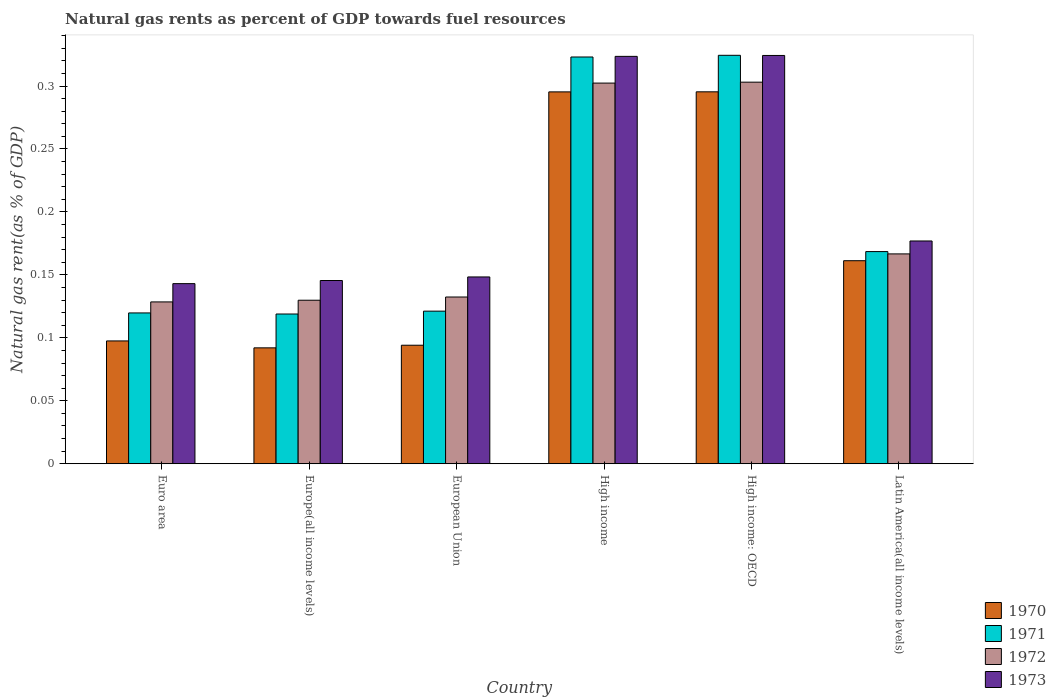How many different coloured bars are there?
Your response must be concise. 4. Are the number of bars on each tick of the X-axis equal?
Your answer should be compact. Yes. What is the label of the 1st group of bars from the left?
Make the answer very short. Euro area. In how many cases, is the number of bars for a given country not equal to the number of legend labels?
Offer a very short reply. 0. What is the natural gas rent in 1970 in Latin America(all income levels)?
Your response must be concise. 0.16. Across all countries, what is the maximum natural gas rent in 1971?
Keep it short and to the point. 0.32. Across all countries, what is the minimum natural gas rent in 1973?
Provide a succinct answer. 0.14. In which country was the natural gas rent in 1971 maximum?
Make the answer very short. High income: OECD. In which country was the natural gas rent in 1972 minimum?
Offer a terse response. Euro area. What is the total natural gas rent in 1972 in the graph?
Make the answer very short. 1.16. What is the difference between the natural gas rent in 1971 in Euro area and that in Europe(all income levels)?
Give a very brief answer. 0. What is the difference between the natural gas rent in 1971 in Euro area and the natural gas rent in 1970 in High income?
Offer a very short reply. -0.18. What is the average natural gas rent in 1973 per country?
Offer a very short reply. 0.21. What is the difference between the natural gas rent of/in 1972 and natural gas rent of/in 1971 in High income: OECD?
Provide a succinct answer. -0.02. In how many countries, is the natural gas rent in 1972 greater than 0.17 %?
Provide a short and direct response. 2. What is the ratio of the natural gas rent in 1972 in High income to that in High income: OECD?
Make the answer very short. 1. Is the natural gas rent in 1971 in Euro area less than that in Europe(all income levels)?
Keep it short and to the point. No. What is the difference between the highest and the second highest natural gas rent in 1971?
Ensure brevity in your answer.  0. What is the difference between the highest and the lowest natural gas rent in 1971?
Give a very brief answer. 0.21. Is it the case that in every country, the sum of the natural gas rent in 1973 and natural gas rent in 1972 is greater than the sum of natural gas rent in 1971 and natural gas rent in 1970?
Your answer should be compact. No. What does the 1st bar from the right in Europe(all income levels) represents?
Offer a terse response. 1973. How many bars are there?
Provide a succinct answer. 24. Are all the bars in the graph horizontal?
Make the answer very short. No. How many countries are there in the graph?
Your response must be concise. 6. What is the difference between two consecutive major ticks on the Y-axis?
Your response must be concise. 0.05. Are the values on the major ticks of Y-axis written in scientific E-notation?
Make the answer very short. No. Does the graph contain any zero values?
Offer a terse response. No. How are the legend labels stacked?
Offer a terse response. Vertical. What is the title of the graph?
Give a very brief answer. Natural gas rents as percent of GDP towards fuel resources. Does "1997" appear as one of the legend labels in the graph?
Provide a short and direct response. No. What is the label or title of the Y-axis?
Your answer should be very brief. Natural gas rent(as % of GDP). What is the Natural gas rent(as % of GDP) in 1970 in Euro area?
Provide a short and direct response. 0.1. What is the Natural gas rent(as % of GDP) of 1971 in Euro area?
Your response must be concise. 0.12. What is the Natural gas rent(as % of GDP) of 1972 in Euro area?
Your answer should be compact. 0.13. What is the Natural gas rent(as % of GDP) of 1973 in Euro area?
Make the answer very short. 0.14. What is the Natural gas rent(as % of GDP) in 1970 in Europe(all income levels)?
Your response must be concise. 0.09. What is the Natural gas rent(as % of GDP) in 1971 in Europe(all income levels)?
Offer a very short reply. 0.12. What is the Natural gas rent(as % of GDP) in 1972 in Europe(all income levels)?
Give a very brief answer. 0.13. What is the Natural gas rent(as % of GDP) of 1973 in Europe(all income levels)?
Ensure brevity in your answer.  0.15. What is the Natural gas rent(as % of GDP) of 1970 in European Union?
Your response must be concise. 0.09. What is the Natural gas rent(as % of GDP) in 1971 in European Union?
Keep it short and to the point. 0.12. What is the Natural gas rent(as % of GDP) in 1972 in European Union?
Offer a terse response. 0.13. What is the Natural gas rent(as % of GDP) in 1973 in European Union?
Give a very brief answer. 0.15. What is the Natural gas rent(as % of GDP) of 1970 in High income?
Provide a succinct answer. 0.3. What is the Natural gas rent(as % of GDP) of 1971 in High income?
Make the answer very short. 0.32. What is the Natural gas rent(as % of GDP) of 1972 in High income?
Offer a terse response. 0.3. What is the Natural gas rent(as % of GDP) in 1973 in High income?
Offer a very short reply. 0.32. What is the Natural gas rent(as % of GDP) of 1970 in High income: OECD?
Provide a short and direct response. 0.3. What is the Natural gas rent(as % of GDP) of 1971 in High income: OECD?
Your answer should be very brief. 0.32. What is the Natural gas rent(as % of GDP) in 1972 in High income: OECD?
Your response must be concise. 0.3. What is the Natural gas rent(as % of GDP) in 1973 in High income: OECD?
Offer a terse response. 0.32. What is the Natural gas rent(as % of GDP) of 1970 in Latin America(all income levels)?
Provide a short and direct response. 0.16. What is the Natural gas rent(as % of GDP) in 1971 in Latin America(all income levels)?
Make the answer very short. 0.17. What is the Natural gas rent(as % of GDP) in 1972 in Latin America(all income levels)?
Your answer should be very brief. 0.17. What is the Natural gas rent(as % of GDP) in 1973 in Latin America(all income levels)?
Offer a very short reply. 0.18. Across all countries, what is the maximum Natural gas rent(as % of GDP) in 1970?
Your answer should be compact. 0.3. Across all countries, what is the maximum Natural gas rent(as % of GDP) of 1971?
Provide a succinct answer. 0.32. Across all countries, what is the maximum Natural gas rent(as % of GDP) of 1972?
Ensure brevity in your answer.  0.3. Across all countries, what is the maximum Natural gas rent(as % of GDP) of 1973?
Provide a succinct answer. 0.32. Across all countries, what is the minimum Natural gas rent(as % of GDP) in 1970?
Offer a terse response. 0.09. Across all countries, what is the minimum Natural gas rent(as % of GDP) of 1971?
Offer a very short reply. 0.12. Across all countries, what is the minimum Natural gas rent(as % of GDP) of 1972?
Your answer should be very brief. 0.13. Across all countries, what is the minimum Natural gas rent(as % of GDP) in 1973?
Ensure brevity in your answer.  0.14. What is the total Natural gas rent(as % of GDP) in 1970 in the graph?
Make the answer very short. 1.04. What is the total Natural gas rent(as % of GDP) of 1971 in the graph?
Provide a succinct answer. 1.18. What is the total Natural gas rent(as % of GDP) of 1972 in the graph?
Your response must be concise. 1.16. What is the total Natural gas rent(as % of GDP) in 1973 in the graph?
Offer a very short reply. 1.26. What is the difference between the Natural gas rent(as % of GDP) in 1970 in Euro area and that in Europe(all income levels)?
Give a very brief answer. 0.01. What is the difference between the Natural gas rent(as % of GDP) in 1971 in Euro area and that in Europe(all income levels)?
Make the answer very short. 0. What is the difference between the Natural gas rent(as % of GDP) of 1972 in Euro area and that in Europe(all income levels)?
Ensure brevity in your answer.  -0. What is the difference between the Natural gas rent(as % of GDP) of 1973 in Euro area and that in Europe(all income levels)?
Provide a succinct answer. -0. What is the difference between the Natural gas rent(as % of GDP) in 1970 in Euro area and that in European Union?
Your answer should be very brief. 0. What is the difference between the Natural gas rent(as % of GDP) of 1971 in Euro area and that in European Union?
Ensure brevity in your answer.  -0. What is the difference between the Natural gas rent(as % of GDP) of 1972 in Euro area and that in European Union?
Provide a short and direct response. -0. What is the difference between the Natural gas rent(as % of GDP) of 1973 in Euro area and that in European Union?
Ensure brevity in your answer.  -0.01. What is the difference between the Natural gas rent(as % of GDP) of 1970 in Euro area and that in High income?
Provide a short and direct response. -0.2. What is the difference between the Natural gas rent(as % of GDP) of 1971 in Euro area and that in High income?
Give a very brief answer. -0.2. What is the difference between the Natural gas rent(as % of GDP) in 1972 in Euro area and that in High income?
Ensure brevity in your answer.  -0.17. What is the difference between the Natural gas rent(as % of GDP) in 1973 in Euro area and that in High income?
Your answer should be very brief. -0.18. What is the difference between the Natural gas rent(as % of GDP) in 1970 in Euro area and that in High income: OECD?
Keep it short and to the point. -0.2. What is the difference between the Natural gas rent(as % of GDP) in 1971 in Euro area and that in High income: OECD?
Make the answer very short. -0.2. What is the difference between the Natural gas rent(as % of GDP) in 1972 in Euro area and that in High income: OECD?
Your answer should be very brief. -0.17. What is the difference between the Natural gas rent(as % of GDP) in 1973 in Euro area and that in High income: OECD?
Offer a very short reply. -0.18. What is the difference between the Natural gas rent(as % of GDP) in 1970 in Euro area and that in Latin America(all income levels)?
Your response must be concise. -0.06. What is the difference between the Natural gas rent(as % of GDP) of 1971 in Euro area and that in Latin America(all income levels)?
Your answer should be compact. -0.05. What is the difference between the Natural gas rent(as % of GDP) of 1972 in Euro area and that in Latin America(all income levels)?
Your answer should be compact. -0.04. What is the difference between the Natural gas rent(as % of GDP) of 1973 in Euro area and that in Latin America(all income levels)?
Ensure brevity in your answer.  -0.03. What is the difference between the Natural gas rent(as % of GDP) of 1970 in Europe(all income levels) and that in European Union?
Make the answer very short. -0. What is the difference between the Natural gas rent(as % of GDP) of 1971 in Europe(all income levels) and that in European Union?
Provide a succinct answer. -0. What is the difference between the Natural gas rent(as % of GDP) of 1972 in Europe(all income levels) and that in European Union?
Your answer should be very brief. -0. What is the difference between the Natural gas rent(as % of GDP) in 1973 in Europe(all income levels) and that in European Union?
Your answer should be compact. -0. What is the difference between the Natural gas rent(as % of GDP) of 1970 in Europe(all income levels) and that in High income?
Provide a succinct answer. -0.2. What is the difference between the Natural gas rent(as % of GDP) of 1971 in Europe(all income levels) and that in High income?
Make the answer very short. -0.2. What is the difference between the Natural gas rent(as % of GDP) in 1972 in Europe(all income levels) and that in High income?
Ensure brevity in your answer.  -0.17. What is the difference between the Natural gas rent(as % of GDP) in 1973 in Europe(all income levels) and that in High income?
Offer a very short reply. -0.18. What is the difference between the Natural gas rent(as % of GDP) of 1970 in Europe(all income levels) and that in High income: OECD?
Provide a short and direct response. -0.2. What is the difference between the Natural gas rent(as % of GDP) of 1971 in Europe(all income levels) and that in High income: OECD?
Provide a short and direct response. -0.21. What is the difference between the Natural gas rent(as % of GDP) in 1972 in Europe(all income levels) and that in High income: OECD?
Your response must be concise. -0.17. What is the difference between the Natural gas rent(as % of GDP) in 1973 in Europe(all income levels) and that in High income: OECD?
Make the answer very short. -0.18. What is the difference between the Natural gas rent(as % of GDP) of 1970 in Europe(all income levels) and that in Latin America(all income levels)?
Give a very brief answer. -0.07. What is the difference between the Natural gas rent(as % of GDP) in 1971 in Europe(all income levels) and that in Latin America(all income levels)?
Ensure brevity in your answer.  -0.05. What is the difference between the Natural gas rent(as % of GDP) of 1972 in Europe(all income levels) and that in Latin America(all income levels)?
Make the answer very short. -0.04. What is the difference between the Natural gas rent(as % of GDP) of 1973 in Europe(all income levels) and that in Latin America(all income levels)?
Offer a terse response. -0.03. What is the difference between the Natural gas rent(as % of GDP) of 1970 in European Union and that in High income?
Your response must be concise. -0.2. What is the difference between the Natural gas rent(as % of GDP) of 1971 in European Union and that in High income?
Make the answer very short. -0.2. What is the difference between the Natural gas rent(as % of GDP) in 1972 in European Union and that in High income?
Offer a very short reply. -0.17. What is the difference between the Natural gas rent(as % of GDP) in 1973 in European Union and that in High income?
Your answer should be compact. -0.18. What is the difference between the Natural gas rent(as % of GDP) in 1970 in European Union and that in High income: OECD?
Your response must be concise. -0.2. What is the difference between the Natural gas rent(as % of GDP) in 1971 in European Union and that in High income: OECD?
Offer a very short reply. -0.2. What is the difference between the Natural gas rent(as % of GDP) of 1972 in European Union and that in High income: OECD?
Your answer should be very brief. -0.17. What is the difference between the Natural gas rent(as % of GDP) in 1973 in European Union and that in High income: OECD?
Your response must be concise. -0.18. What is the difference between the Natural gas rent(as % of GDP) in 1970 in European Union and that in Latin America(all income levels)?
Offer a terse response. -0.07. What is the difference between the Natural gas rent(as % of GDP) of 1971 in European Union and that in Latin America(all income levels)?
Provide a succinct answer. -0.05. What is the difference between the Natural gas rent(as % of GDP) in 1972 in European Union and that in Latin America(all income levels)?
Your response must be concise. -0.03. What is the difference between the Natural gas rent(as % of GDP) in 1973 in European Union and that in Latin America(all income levels)?
Provide a succinct answer. -0.03. What is the difference between the Natural gas rent(as % of GDP) of 1971 in High income and that in High income: OECD?
Your answer should be compact. -0. What is the difference between the Natural gas rent(as % of GDP) of 1972 in High income and that in High income: OECD?
Provide a short and direct response. -0. What is the difference between the Natural gas rent(as % of GDP) of 1973 in High income and that in High income: OECD?
Your answer should be compact. -0. What is the difference between the Natural gas rent(as % of GDP) of 1970 in High income and that in Latin America(all income levels)?
Offer a very short reply. 0.13. What is the difference between the Natural gas rent(as % of GDP) of 1971 in High income and that in Latin America(all income levels)?
Your answer should be compact. 0.15. What is the difference between the Natural gas rent(as % of GDP) in 1972 in High income and that in Latin America(all income levels)?
Give a very brief answer. 0.14. What is the difference between the Natural gas rent(as % of GDP) of 1973 in High income and that in Latin America(all income levels)?
Offer a terse response. 0.15. What is the difference between the Natural gas rent(as % of GDP) of 1970 in High income: OECD and that in Latin America(all income levels)?
Ensure brevity in your answer.  0.13. What is the difference between the Natural gas rent(as % of GDP) in 1971 in High income: OECD and that in Latin America(all income levels)?
Your response must be concise. 0.16. What is the difference between the Natural gas rent(as % of GDP) of 1972 in High income: OECD and that in Latin America(all income levels)?
Provide a short and direct response. 0.14. What is the difference between the Natural gas rent(as % of GDP) in 1973 in High income: OECD and that in Latin America(all income levels)?
Offer a very short reply. 0.15. What is the difference between the Natural gas rent(as % of GDP) in 1970 in Euro area and the Natural gas rent(as % of GDP) in 1971 in Europe(all income levels)?
Your answer should be compact. -0.02. What is the difference between the Natural gas rent(as % of GDP) in 1970 in Euro area and the Natural gas rent(as % of GDP) in 1972 in Europe(all income levels)?
Offer a very short reply. -0.03. What is the difference between the Natural gas rent(as % of GDP) of 1970 in Euro area and the Natural gas rent(as % of GDP) of 1973 in Europe(all income levels)?
Provide a short and direct response. -0.05. What is the difference between the Natural gas rent(as % of GDP) in 1971 in Euro area and the Natural gas rent(as % of GDP) in 1972 in Europe(all income levels)?
Ensure brevity in your answer.  -0.01. What is the difference between the Natural gas rent(as % of GDP) of 1971 in Euro area and the Natural gas rent(as % of GDP) of 1973 in Europe(all income levels)?
Ensure brevity in your answer.  -0.03. What is the difference between the Natural gas rent(as % of GDP) in 1972 in Euro area and the Natural gas rent(as % of GDP) in 1973 in Europe(all income levels)?
Ensure brevity in your answer.  -0.02. What is the difference between the Natural gas rent(as % of GDP) in 1970 in Euro area and the Natural gas rent(as % of GDP) in 1971 in European Union?
Provide a succinct answer. -0.02. What is the difference between the Natural gas rent(as % of GDP) of 1970 in Euro area and the Natural gas rent(as % of GDP) of 1972 in European Union?
Offer a very short reply. -0.03. What is the difference between the Natural gas rent(as % of GDP) of 1970 in Euro area and the Natural gas rent(as % of GDP) of 1973 in European Union?
Offer a very short reply. -0.05. What is the difference between the Natural gas rent(as % of GDP) in 1971 in Euro area and the Natural gas rent(as % of GDP) in 1972 in European Union?
Provide a short and direct response. -0.01. What is the difference between the Natural gas rent(as % of GDP) in 1971 in Euro area and the Natural gas rent(as % of GDP) in 1973 in European Union?
Give a very brief answer. -0.03. What is the difference between the Natural gas rent(as % of GDP) of 1972 in Euro area and the Natural gas rent(as % of GDP) of 1973 in European Union?
Offer a very short reply. -0.02. What is the difference between the Natural gas rent(as % of GDP) in 1970 in Euro area and the Natural gas rent(as % of GDP) in 1971 in High income?
Your answer should be compact. -0.23. What is the difference between the Natural gas rent(as % of GDP) of 1970 in Euro area and the Natural gas rent(as % of GDP) of 1972 in High income?
Provide a succinct answer. -0.2. What is the difference between the Natural gas rent(as % of GDP) of 1970 in Euro area and the Natural gas rent(as % of GDP) of 1973 in High income?
Offer a very short reply. -0.23. What is the difference between the Natural gas rent(as % of GDP) in 1971 in Euro area and the Natural gas rent(as % of GDP) in 1972 in High income?
Keep it short and to the point. -0.18. What is the difference between the Natural gas rent(as % of GDP) of 1971 in Euro area and the Natural gas rent(as % of GDP) of 1973 in High income?
Keep it short and to the point. -0.2. What is the difference between the Natural gas rent(as % of GDP) in 1972 in Euro area and the Natural gas rent(as % of GDP) in 1973 in High income?
Your answer should be very brief. -0.2. What is the difference between the Natural gas rent(as % of GDP) in 1970 in Euro area and the Natural gas rent(as % of GDP) in 1971 in High income: OECD?
Offer a very short reply. -0.23. What is the difference between the Natural gas rent(as % of GDP) in 1970 in Euro area and the Natural gas rent(as % of GDP) in 1972 in High income: OECD?
Keep it short and to the point. -0.21. What is the difference between the Natural gas rent(as % of GDP) of 1970 in Euro area and the Natural gas rent(as % of GDP) of 1973 in High income: OECD?
Keep it short and to the point. -0.23. What is the difference between the Natural gas rent(as % of GDP) of 1971 in Euro area and the Natural gas rent(as % of GDP) of 1972 in High income: OECD?
Your answer should be compact. -0.18. What is the difference between the Natural gas rent(as % of GDP) of 1971 in Euro area and the Natural gas rent(as % of GDP) of 1973 in High income: OECD?
Offer a terse response. -0.2. What is the difference between the Natural gas rent(as % of GDP) of 1972 in Euro area and the Natural gas rent(as % of GDP) of 1973 in High income: OECD?
Give a very brief answer. -0.2. What is the difference between the Natural gas rent(as % of GDP) of 1970 in Euro area and the Natural gas rent(as % of GDP) of 1971 in Latin America(all income levels)?
Provide a succinct answer. -0.07. What is the difference between the Natural gas rent(as % of GDP) in 1970 in Euro area and the Natural gas rent(as % of GDP) in 1972 in Latin America(all income levels)?
Ensure brevity in your answer.  -0.07. What is the difference between the Natural gas rent(as % of GDP) in 1970 in Euro area and the Natural gas rent(as % of GDP) in 1973 in Latin America(all income levels)?
Your response must be concise. -0.08. What is the difference between the Natural gas rent(as % of GDP) of 1971 in Euro area and the Natural gas rent(as % of GDP) of 1972 in Latin America(all income levels)?
Your answer should be very brief. -0.05. What is the difference between the Natural gas rent(as % of GDP) of 1971 in Euro area and the Natural gas rent(as % of GDP) of 1973 in Latin America(all income levels)?
Provide a succinct answer. -0.06. What is the difference between the Natural gas rent(as % of GDP) of 1972 in Euro area and the Natural gas rent(as % of GDP) of 1973 in Latin America(all income levels)?
Provide a short and direct response. -0.05. What is the difference between the Natural gas rent(as % of GDP) in 1970 in Europe(all income levels) and the Natural gas rent(as % of GDP) in 1971 in European Union?
Offer a terse response. -0.03. What is the difference between the Natural gas rent(as % of GDP) of 1970 in Europe(all income levels) and the Natural gas rent(as % of GDP) of 1972 in European Union?
Provide a short and direct response. -0.04. What is the difference between the Natural gas rent(as % of GDP) in 1970 in Europe(all income levels) and the Natural gas rent(as % of GDP) in 1973 in European Union?
Your response must be concise. -0.06. What is the difference between the Natural gas rent(as % of GDP) of 1971 in Europe(all income levels) and the Natural gas rent(as % of GDP) of 1972 in European Union?
Your answer should be compact. -0.01. What is the difference between the Natural gas rent(as % of GDP) in 1971 in Europe(all income levels) and the Natural gas rent(as % of GDP) in 1973 in European Union?
Provide a short and direct response. -0.03. What is the difference between the Natural gas rent(as % of GDP) in 1972 in Europe(all income levels) and the Natural gas rent(as % of GDP) in 1973 in European Union?
Provide a short and direct response. -0.02. What is the difference between the Natural gas rent(as % of GDP) in 1970 in Europe(all income levels) and the Natural gas rent(as % of GDP) in 1971 in High income?
Keep it short and to the point. -0.23. What is the difference between the Natural gas rent(as % of GDP) of 1970 in Europe(all income levels) and the Natural gas rent(as % of GDP) of 1972 in High income?
Offer a terse response. -0.21. What is the difference between the Natural gas rent(as % of GDP) of 1970 in Europe(all income levels) and the Natural gas rent(as % of GDP) of 1973 in High income?
Your answer should be compact. -0.23. What is the difference between the Natural gas rent(as % of GDP) of 1971 in Europe(all income levels) and the Natural gas rent(as % of GDP) of 1972 in High income?
Your response must be concise. -0.18. What is the difference between the Natural gas rent(as % of GDP) of 1971 in Europe(all income levels) and the Natural gas rent(as % of GDP) of 1973 in High income?
Give a very brief answer. -0.2. What is the difference between the Natural gas rent(as % of GDP) of 1972 in Europe(all income levels) and the Natural gas rent(as % of GDP) of 1973 in High income?
Your answer should be very brief. -0.19. What is the difference between the Natural gas rent(as % of GDP) in 1970 in Europe(all income levels) and the Natural gas rent(as % of GDP) in 1971 in High income: OECD?
Offer a very short reply. -0.23. What is the difference between the Natural gas rent(as % of GDP) of 1970 in Europe(all income levels) and the Natural gas rent(as % of GDP) of 1972 in High income: OECD?
Your answer should be very brief. -0.21. What is the difference between the Natural gas rent(as % of GDP) of 1970 in Europe(all income levels) and the Natural gas rent(as % of GDP) of 1973 in High income: OECD?
Give a very brief answer. -0.23. What is the difference between the Natural gas rent(as % of GDP) in 1971 in Europe(all income levels) and the Natural gas rent(as % of GDP) in 1972 in High income: OECD?
Your answer should be compact. -0.18. What is the difference between the Natural gas rent(as % of GDP) of 1971 in Europe(all income levels) and the Natural gas rent(as % of GDP) of 1973 in High income: OECD?
Ensure brevity in your answer.  -0.21. What is the difference between the Natural gas rent(as % of GDP) in 1972 in Europe(all income levels) and the Natural gas rent(as % of GDP) in 1973 in High income: OECD?
Make the answer very short. -0.19. What is the difference between the Natural gas rent(as % of GDP) of 1970 in Europe(all income levels) and the Natural gas rent(as % of GDP) of 1971 in Latin America(all income levels)?
Provide a succinct answer. -0.08. What is the difference between the Natural gas rent(as % of GDP) in 1970 in Europe(all income levels) and the Natural gas rent(as % of GDP) in 1972 in Latin America(all income levels)?
Keep it short and to the point. -0.07. What is the difference between the Natural gas rent(as % of GDP) of 1970 in Europe(all income levels) and the Natural gas rent(as % of GDP) of 1973 in Latin America(all income levels)?
Your answer should be compact. -0.08. What is the difference between the Natural gas rent(as % of GDP) in 1971 in Europe(all income levels) and the Natural gas rent(as % of GDP) in 1972 in Latin America(all income levels)?
Your answer should be very brief. -0.05. What is the difference between the Natural gas rent(as % of GDP) in 1971 in Europe(all income levels) and the Natural gas rent(as % of GDP) in 1973 in Latin America(all income levels)?
Keep it short and to the point. -0.06. What is the difference between the Natural gas rent(as % of GDP) in 1972 in Europe(all income levels) and the Natural gas rent(as % of GDP) in 1973 in Latin America(all income levels)?
Make the answer very short. -0.05. What is the difference between the Natural gas rent(as % of GDP) of 1970 in European Union and the Natural gas rent(as % of GDP) of 1971 in High income?
Your answer should be very brief. -0.23. What is the difference between the Natural gas rent(as % of GDP) in 1970 in European Union and the Natural gas rent(as % of GDP) in 1972 in High income?
Your answer should be compact. -0.21. What is the difference between the Natural gas rent(as % of GDP) of 1970 in European Union and the Natural gas rent(as % of GDP) of 1973 in High income?
Make the answer very short. -0.23. What is the difference between the Natural gas rent(as % of GDP) in 1971 in European Union and the Natural gas rent(as % of GDP) in 1972 in High income?
Make the answer very short. -0.18. What is the difference between the Natural gas rent(as % of GDP) in 1971 in European Union and the Natural gas rent(as % of GDP) in 1973 in High income?
Your answer should be very brief. -0.2. What is the difference between the Natural gas rent(as % of GDP) in 1972 in European Union and the Natural gas rent(as % of GDP) in 1973 in High income?
Offer a terse response. -0.19. What is the difference between the Natural gas rent(as % of GDP) of 1970 in European Union and the Natural gas rent(as % of GDP) of 1971 in High income: OECD?
Give a very brief answer. -0.23. What is the difference between the Natural gas rent(as % of GDP) of 1970 in European Union and the Natural gas rent(as % of GDP) of 1972 in High income: OECD?
Your answer should be very brief. -0.21. What is the difference between the Natural gas rent(as % of GDP) of 1970 in European Union and the Natural gas rent(as % of GDP) of 1973 in High income: OECD?
Offer a very short reply. -0.23. What is the difference between the Natural gas rent(as % of GDP) of 1971 in European Union and the Natural gas rent(as % of GDP) of 1972 in High income: OECD?
Offer a terse response. -0.18. What is the difference between the Natural gas rent(as % of GDP) in 1971 in European Union and the Natural gas rent(as % of GDP) in 1973 in High income: OECD?
Offer a terse response. -0.2. What is the difference between the Natural gas rent(as % of GDP) in 1972 in European Union and the Natural gas rent(as % of GDP) in 1973 in High income: OECD?
Your answer should be compact. -0.19. What is the difference between the Natural gas rent(as % of GDP) of 1970 in European Union and the Natural gas rent(as % of GDP) of 1971 in Latin America(all income levels)?
Keep it short and to the point. -0.07. What is the difference between the Natural gas rent(as % of GDP) in 1970 in European Union and the Natural gas rent(as % of GDP) in 1972 in Latin America(all income levels)?
Make the answer very short. -0.07. What is the difference between the Natural gas rent(as % of GDP) of 1970 in European Union and the Natural gas rent(as % of GDP) of 1973 in Latin America(all income levels)?
Offer a very short reply. -0.08. What is the difference between the Natural gas rent(as % of GDP) of 1971 in European Union and the Natural gas rent(as % of GDP) of 1972 in Latin America(all income levels)?
Provide a succinct answer. -0.05. What is the difference between the Natural gas rent(as % of GDP) in 1971 in European Union and the Natural gas rent(as % of GDP) in 1973 in Latin America(all income levels)?
Keep it short and to the point. -0.06. What is the difference between the Natural gas rent(as % of GDP) in 1972 in European Union and the Natural gas rent(as % of GDP) in 1973 in Latin America(all income levels)?
Offer a terse response. -0.04. What is the difference between the Natural gas rent(as % of GDP) of 1970 in High income and the Natural gas rent(as % of GDP) of 1971 in High income: OECD?
Make the answer very short. -0.03. What is the difference between the Natural gas rent(as % of GDP) in 1970 in High income and the Natural gas rent(as % of GDP) in 1972 in High income: OECD?
Your response must be concise. -0.01. What is the difference between the Natural gas rent(as % of GDP) of 1970 in High income and the Natural gas rent(as % of GDP) of 1973 in High income: OECD?
Your answer should be compact. -0.03. What is the difference between the Natural gas rent(as % of GDP) of 1971 in High income and the Natural gas rent(as % of GDP) of 1973 in High income: OECD?
Ensure brevity in your answer.  -0. What is the difference between the Natural gas rent(as % of GDP) in 1972 in High income and the Natural gas rent(as % of GDP) in 1973 in High income: OECD?
Your answer should be very brief. -0.02. What is the difference between the Natural gas rent(as % of GDP) in 1970 in High income and the Natural gas rent(as % of GDP) in 1971 in Latin America(all income levels)?
Offer a very short reply. 0.13. What is the difference between the Natural gas rent(as % of GDP) of 1970 in High income and the Natural gas rent(as % of GDP) of 1972 in Latin America(all income levels)?
Your answer should be very brief. 0.13. What is the difference between the Natural gas rent(as % of GDP) of 1970 in High income and the Natural gas rent(as % of GDP) of 1973 in Latin America(all income levels)?
Make the answer very short. 0.12. What is the difference between the Natural gas rent(as % of GDP) of 1971 in High income and the Natural gas rent(as % of GDP) of 1972 in Latin America(all income levels)?
Your answer should be very brief. 0.16. What is the difference between the Natural gas rent(as % of GDP) in 1971 in High income and the Natural gas rent(as % of GDP) in 1973 in Latin America(all income levels)?
Provide a succinct answer. 0.15. What is the difference between the Natural gas rent(as % of GDP) of 1972 in High income and the Natural gas rent(as % of GDP) of 1973 in Latin America(all income levels)?
Your response must be concise. 0.13. What is the difference between the Natural gas rent(as % of GDP) in 1970 in High income: OECD and the Natural gas rent(as % of GDP) in 1971 in Latin America(all income levels)?
Make the answer very short. 0.13. What is the difference between the Natural gas rent(as % of GDP) of 1970 in High income: OECD and the Natural gas rent(as % of GDP) of 1972 in Latin America(all income levels)?
Your answer should be very brief. 0.13. What is the difference between the Natural gas rent(as % of GDP) of 1970 in High income: OECD and the Natural gas rent(as % of GDP) of 1973 in Latin America(all income levels)?
Provide a succinct answer. 0.12. What is the difference between the Natural gas rent(as % of GDP) of 1971 in High income: OECD and the Natural gas rent(as % of GDP) of 1972 in Latin America(all income levels)?
Ensure brevity in your answer.  0.16. What is the difference between the Natural gas rent(as % of GDP) in 1971 in High income: OECD and the Natural gas rent(as % of GDP) in 1973 in Latin America(all income levels)?
Keep it short and to the point. 0.15. What is the difference between the Natural gas rent(as % of GDP) of 1972 in High income: OECD and the Natural gas rent(as % of GDP) of 1973 in Latin America(all income levels)?
Keep it short and to the point. 0.13. What is the average Natural gas rent(as % of GDP) of 1970 per country?
Your answer should be compact. 0.17. What is the average Natural gas rent(as % of GDP) in 1971 per country?
Offer a terse response. 0.2. What is the average Natural gas rent(as % of GDP) in 1972 per country?
Your answer should be compact. 0.19. What is the average Natural gas rent(as % of GDP) in 1973 per country?
Your response must be concise. 0.21. What is the difference between the Natural gas rent(as % of GDP) in 1970 and Natural gas rent(as % of GDP) in 1971 in Euro area?
Your answer should be compact. -0.02. What is the difference between the Natural gas rent(as % of GDP) in 1970 and Natural gas rent(as % of GDP) in 1972 in Euro area?
Your response must be concise. -0.03. What is the difference between the Natural gas rent(as % of GDP) of 1970 and Natural gas rent(as % of GDP) of 1973 in Euro area?
Give a very brief answer. -0.05. What is the difference between the Natural gas rent(as % of GDP) in 1971 and Natural gas rent(as % of GDP) in 1972 in Euro area?
Provide a succinct answer. -0.01. What is the difference between the Natural gas rent(as % of GDP) of 1971 and Natural gas rent(as % of GDP) of 1973 in Euro area?
Give a very brief answer. -0.02. What is the difference between the Natural gas rent(as % of GDP) of 1972 and Natural gas rent(as % of GDP) of 1973 in Euro area?
Your answer should be very brief. -0.01. What is the difference between the Natural gas rent(as % of GDP) in 1970 and Natural gas rent(as % of GDP) in 1971 in Europe(all income levels)?
Offer a terse response. -0.03. What is the difference between the Natural gas rent(as % of GDP) in 1970 and Natural gas rent(as % of GDP) in 1972 in Europe(all income levels)?
Your answer should be very brief. -0.04. What is the difference between the Natural gas rent(as % of GDP) in 1970 and Natural gas rent(as % of GDP) in 1973 in Europe(all income levels)?
Your response must be concise. -0.05. What is the difference between the Natural gas rent(as % of GDP) of 1971 and Natural gas rent(as % of GDP) of 1972 in Europe(all income levels)?
Keep it short and to the point. -0.01. What is the difference between the Natural gas rent(as % of GDP) of 1971 and Natural gas rent(as % of GDP) of 1973 in Europe(all income levels)?
Your response must be concise. -0.03. What is the difference between the Natural gas rent(as % of GDP) in 1972 and Natural gas rent(as % of GDP) in 1973 in Europe(all income levels)?
Offer a very short reply. -0.02. What is the difference between the Natural gas rent(as % of GDP) in 1970 and Natural gas rent(as % of GDP) in 1971 in European Union?
Offer a terse response. -0.03. What is the difference between the Natural gas rent(as % of GDP) in 1970 and Natural gas rent(as % of GDP) in 1972 in European Union?
Your response must be concise. -0.04. What is the difference between the Natural gas rent(as % of GDP) of 1970 and Natural gas rent(as % of GDP) of 1973 in European Union?
Make the answer very short. -0.05. What is the difference between the Natural gas rent(as % of GDP) of 1971 and Natural gas rent(as % of GDP) of 1972 in European Union?
Your answer should be compact. -0.01. What is the difference between the Natural gas rent(as % of GDP) in 1971 and Natural gas rent(as % of GDP) in 1973 in European Union?
Give a very brief answer. -0.03. What is the difference between the Natural gas rent(as % of GDP) in 1972 and Natural gas rent(as % of GDP) in 1973 in European Union?
Provide a succinct answer. -0.02. What is the difference between the Natural gas rent(as % of GDP) of 1970 and Natural gas rent(as % of GDP) of 1971 in High income?
Give a very brief answer. -0.03. What is the difference between the Natural gas rent(as % of GDP) of 1970 and Natural gas rent(as % of GDP) of 1972 in High income?
Provide a short and direct response. -0.01. What is the difference between the Natural gas rent(as % of GDP) in 1970 and Natural gas rent(as % of GDP) in 1973 in High income?
Your answer should be very brief. -0.03. What is the difference between the Natural gas rent(as % of GDP) in 1971 and Natural gas rent(as % of GDP) in 1972 in High income?
Your response must be concise. 0.02. What is the difference between the Natural gas rent(as % of GDP) in 1971 and Natural gas rent(as % of GDP) in 1973 in High income?
Provide a succinct answer. -0. What is the difference between the Natural gas rent(as % of GDP) of 1972 and Natural gas rent(as % of GDP) of 1973 in High income?
Your answer should be very brief. -0.02. What is the difference between the Natural gas rent(as % of GDP) of 1970 and Natural gas rent(as % of GDP) of 1971 in High income: OECD?
Offer a terse response. -0.03. What is the difference between the Natural gas rent(as % of GDP) in 1970 and Natural gas rent(as % of GDP) in 1972 in High income: OECD?
Make the answer very short. -0.01. What is the difference between the Natural gas rent(as % of GDP) of 1970 and Natural gas rent(as % of GDP) of 1973 in High income: OECD?
Make the answer very short. -0.03. What is the difference between the Natural gas rent(as % of GDP) in 1971 and Natural gas rent(as % of GDP) in 1972 in High income: OECD?
Make the answer very short. 0.02. What is the difference between the Natural gas rent(as % of GDP) in 1972 and Natural gas rent(as % of GDP) in 1973 in High income: OECD?
Your answer should be very brief. -0.02. What is the difference between the Natural gas rent(as % of GDP) of 1970 and Natural gas rent(as % of GDP) of 1971 in Latin America(all income levels)?
Give a very brief answer. -0.01. What is the difference between the Natural gas rent(as % of GDP) of 1970 and Natural gas rent(as % of GDP) of 1972 in Latin America(all income levels)?
Offer a terse response. -0.01. What is the difference between the Natural gas rent(as % of GDP) in 1970 and Natural gas rent(as % of GDP) in 1973 in Latin America(all income levels)?
Your answer should be very brief. -0.02. What is the difference between the Natural gas rent(as % of GDP) in 1971 and Natural gas rent(as % of GDP) in 1972 in Latin America(all income levels)?
Your answer should be compact. 0. What is the difference between the Natural gas rent(as % of GDP) of 1971 and Natural gas rent(as % of GDP) of 1973 in Latin America(all income levels)?
Provide a succinct answer. -0.01. What is the difference between the Natural gas rent(as % of GDP) in 1972 and Natural gas rent(as % of GDP) in 1973 in Latin America(all income levels)?
Offer a very short reply. -0.01. What is the ratio of the Natural gas rent(as % of GDP) of 1970 in Euro area to that in Europe(all income levels)?
Give a very brief answer. 1.06. What is the ratio of the Natural gas rent(as % of GDP) of 1973 in Euro area to that in Europe(all income levels)?
Offer a very short reply. 0.98. What is the ratio of the Natural gas rent(as % of GDP) of 1970 in Euro area to that in European Union?
Make the answer very short. 1.04. What is the ratio of the Natural gas rent(as % of GDP) of 1971 in Euro area to that in European Union?
Keep it short and to the point. 0.99. What is the ratio of the Natural gas rent(as % of GDP) in 1972 in Euro area to that in European Union?
Your answer should be compact. 0.97. What is the ratio of the Natural gas rent(as % of GDP) of 1973 in Euro area to that in European Union?
Ensure brevity in your answer.  0.96. What is the ratio of the Natural gas rent(as % of GDP) in 1970 in Euro area to that in High income?
Your answer should be very brief. 0.33. What is the ratio of the Natural gas rent(as % of GDP) of 1971 in Euro area to that in High income?
Provide a short and direct response. 0.37. What is the ratio of the Natural gas rent(as % of GDP) of 1972 in Euro area to that in High income?
Your answer should be compact. 0.43. What is the ratio of the Natural gas rent(as % of GDP) in 1973 in Euro area to that in High income?
Keep it short and to the point. 0.44. What is the ratio of the Natural gas rent(as % of GDP) in 1970 in Euro area to that in High income: OECD?
Provide a succinct answer. 0.33. What is the ratio of the Natural gas rent(as % of GDP) in 1971 in Euro area to that in High income: OECD?
Ensure brevity in your answer.  0.37. What is the ratio of the Natural gas rent(as % of GDP) of 1972 in Euro area to that in High income: OECD?
Make the answer very short. 0.42. What is the ratio of the Natural gas rent(as % of GDP) in 1973 in Euro area to that in High income: OECD?
Your answer should be compact. 0.44. What is the ratio of the Natural gas rent(as % of GDP) in 1970 in Euro area to that in Latin America(all income levels)?
Offer a very short reply. 0.6. What is the ratio of the Natural gas rent(as % of GDP) in 1971 in Euro area to that in Latin America(all income levels)?
Offer a very short reply. 0.71. What is the ratio of the Natural gas rent(as % of GDP) of 1972 in Euro area to that in Latin America(all income levels)?
Provide a short and direct response. 0.77. What is the ratio of the Natural gas rent(as % of GDP) in 1973 in Euro area to that in Latin America(all income levels)?
Your answer should be compact. 0.81. What is the ratio of the Natural gas rent(as % of GDP) of 1970 in Europe(all income levels) to that in European Union?
Offer a terse response. 0.98. What is the ratio of the Natural gas rent(as % of GDP) of 1971 in Europe(all income levels) to that in European Union?
Your response must be concise. 0.98. What is the ratio of the Natural gas rent(as % of GDP) in 1972 in Europe(all income levels) to that in European Union?
Provide a succinct answer. 0.98. What is the ratio of the Natural gas rent(as % of GDP) of 1973 in Europe(all income levels) to that in European Union?
Make the answer very short. 0.98. What is the ratio of the Natural gas rent(as % of GDP) in 1970 in Europe(all income levels) to that in High income?
Your response must be concise. 0.31. What is the ratio of the Natural gas rent(as % of GDP) of 1971 in Europe(all income levels) to that in High income?
Make the answer very short. 0.37. What is the ratio of the Natural gas rent(as % of GDP) in 1972 in Europe(all income levels) to that in High income?
Make the answer very short. 0.43. What is the ratio of the Natural gas rent(as % of GDP) of 1973 in Europe(all income levels) to that in High income?
Your response must be concise. 0.45. What is the ratio of the Natural gas rent(as % of GDP) in 1970 in Europe(all income levels) to that in High income: OECD?
Ensure brevity in your answer.  0.31. What is the ratio of the Natural gas rent(as % of GDP) in 1971 in Europe(all income levels) to that in High income: OECD?
Offer a terse response. 0.37. What is the ratio of the Natural gas rent(as % of GDP) in 1972 in Europe(all income levels) to that in High income: OECD?
Offer a very short reply. 0.43. What is the ratio of the Natural gas rent(as % of GDP) of 1973 in Europe(all income levels) to that in High income: OECD?
Make the answer very short. 0.45. What is the ratio of the Natural gas rent(as % of GDP) in 1970 in Europe(all income levels) to that in Latin America(all income levels)?
Your answer should be very brief. 0.57. What is the ratio of the Natural gas rent(as % of GDP) in 1971 in Europe(all income levels) to that in Latin America(all income levels)?
Your answer should be very brief. 0.71. What is the ratio of the Natural gas rent(as % of GDP) of 1972 in Europe(all income levels) to that in Latin America(all income levels)?
Your answer should be compact. 0.78. What is the ratio of the Natural gas rent(as % of GDP) in 1973 in Europe(all income levels) to that in Latin America(all income levels)?
Your answer should be compact. 0.82. What is the ratio of the Natural gas rent(as % of GDP) of 1970 in European Union to that in High income?
Provide a short and direct response. 0.32. What is the ratio of the Natural gas rent(as % of GDP) in 1971 in European Union to that in High income?
Offer a terse response. 0.38. What is the ratio of the Natural gas rent(as % of GDP) of 1972 in European Union to that in High income?
Give a very brief answer. 0.44. What is the ratio of the Natural gas rent(as % of GDP) in 1973 in European Union to that in High income?
Give a very brief answer. 0.46. What is the ratio of the Natural gas rent(as % of GDP) of 1970 in European Union to that in High income: OECD?
Offer a very short reply. 0.32. What is the ratio of the Natural gas rent(as % of GDP) in 1971 in European Union to that in High income: OECD?
Your response must be concise. 0.37. What is the ratio of the Natural gas rent(as % of GDP) in 1972 in European Union to that in High income: OECD?
Your response must be concise. 0.44. What is the ratio of the Natural gas rent(as % of GDP) in 1973 in European Union to that in High income: OECD?
Offer a very short reply. 0.46. What is the ratio of the Natural gas rent(as % of GDP) of 1970 in European Union to that in Latin America(all income levels)?
Provide a succinct answer. 0.58. What is the ratio of the Natural gas rent(as % of GDP) of 1971 in European Union to that in Latin America(all income levels)?
Offer a very short reply. 0.72. What is the ratio of the Natural gas rent(as % of GDP) of 1972 in European Union to that in Latin America(all income levels)?
Provide a succinct answer. 0.79. What is the ratio of the Natural gas rent(as % of GDP) in 1973 in European Union to that in Latin America(all income levels)?
Offer a very short reply. 0.84. What is the ratio of the Natural gas rent(as % of GDP) in 1970 in High income to that in High income: OECD?
Your answer should be compact. 1. What is the ratio of the Natural gas rent(as % of GDP) of 1970 in High income to that in Latin America(all income levels)?
Provide a short and direct response. 1.83. What is the ratio of the Natural gas rent(as % of GDP) in 1971 in High income to that in Latin America(all income levels)?
Your response must be concise. 1.92. What is the ratio of the Natural gas rent(as % of GDP) of 1972 in High income to that in Latin America(all income levels)?
Offer a very short reply. 1.81. What is the ratio of the Natural gas rent(as % of GDP) in 1973 in High income to that in Latin America(all income levels)?
Your response must be concise. 1.83. What is the ratio of the Natural gas rent(as % of GDP) in 1970 in High income: OECD to that in Latin America(all income levels)?
Provide a succinct answer. 1.83. What is the ratio of the Natural gas rent(as % of GDP) of 1971 in High income: OECD to that in Latin America(all income levels)?
Provide a short and direct response. 1.93. What is the ratio of the Natural gas rent(as % of GDP) in 1972 in High income: OECD to that in Latin America(all income levels)?
Your response must be concise. 1.82. What is the ratio of the Natural gas rent(as % of GDP) of 1973 in High income: OECD to that in Latin America(all income levels)?
Offer a very short reply. 1.83. What is the difference between the highest and the second highest Natural gas rent(as % of GDP) of 1970?
Offer a terse response. 0. What is the difference between the highest and the second highest Natural gas rent(as % of GDP) in 1971?
Make the answer very short. 0. What is the difference between the highest and the second highest Natural gas rent(as % of GDP) of 1972?
Offer a very short reply. 0. What is the difference between the highest and the second highest Natural gas rent(as % of GDP) in 1973?
Provide a short and direct response. 0. What is the difference between the highest and the lowest Natural gas rent(as % of GDP) in 1970?
Make the answer very short. 0.2. What is the difference between the highest and the lowest Natural gas rent(as % of GDP) of 1971?
Ensure brevity in your answer.  0.21. What is the difference between the highest and the lowest Natural gas rent(as % of GDP) in 1972?
Offer a terse response. 0.17. What is the difference between the highest and the lowest Natural gas rent(as % of GDP) of 1973?
Your answer should be compact. 0.18. 